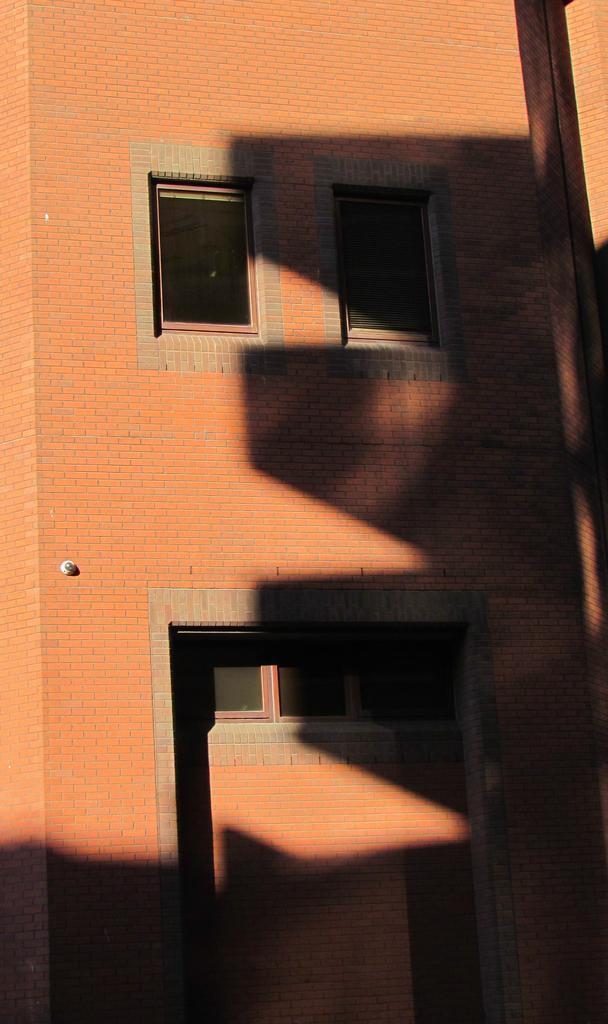How would you summarize this image in a sentence or two? In this image, we can see a building with some windows. We can also see an object on the building. 